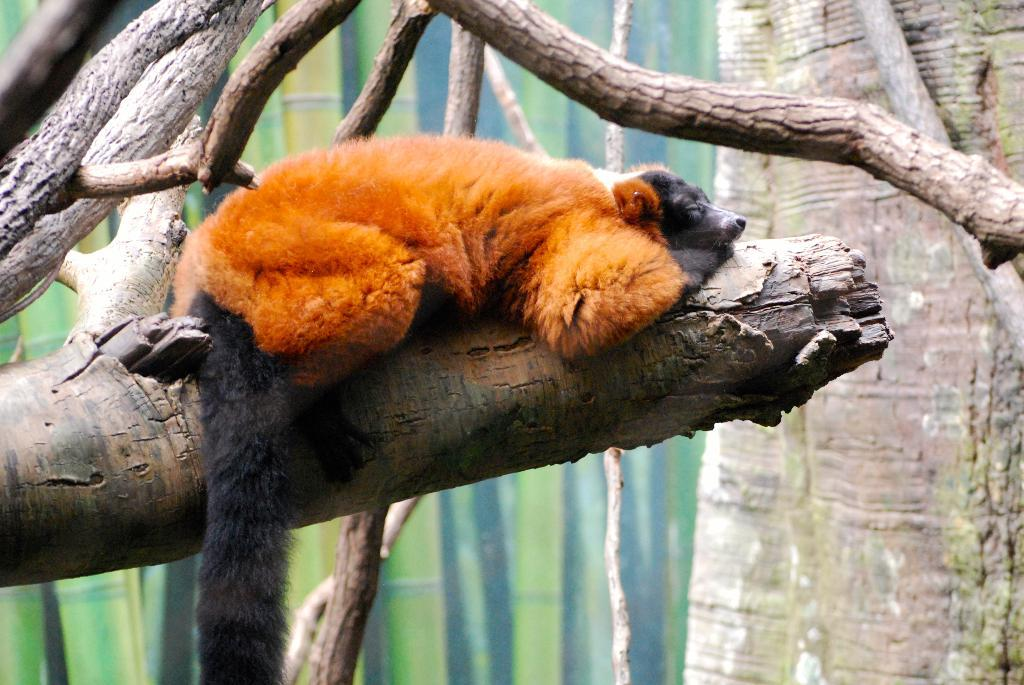What type of animal is in the image? There is a red panda in the image. Where is the red panda located? The red panda is on a branch of a tree. What else can be seen in the image besides the red panda? There are other plants and trees present in the image. Can you read the note that the red panda is holding in the image? There is no note present in the image; the red panda is not holding anything. 